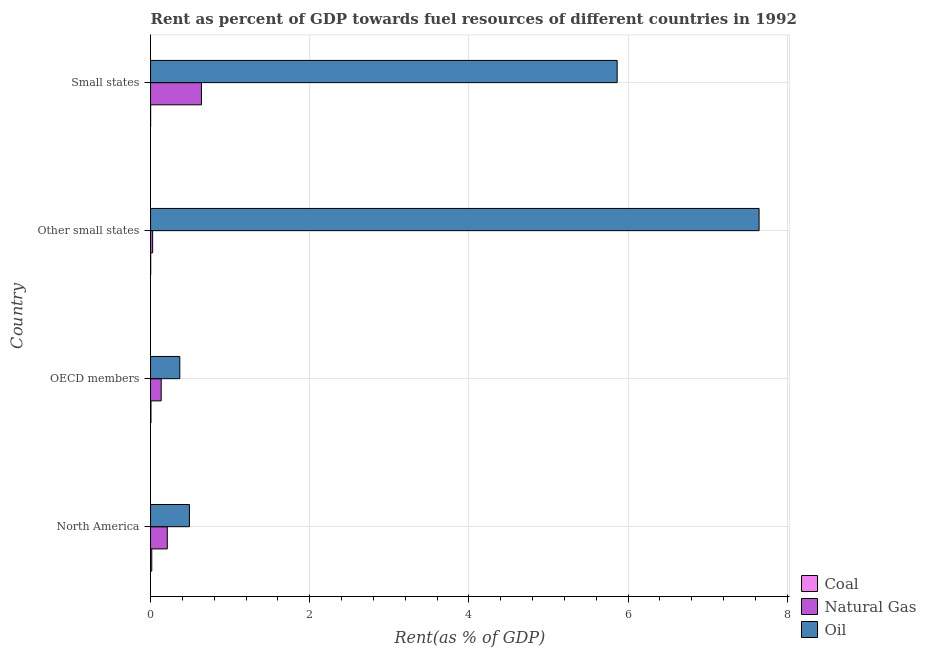Are the number of bars per tick equal to the number of legend labels?
Your answer should be very brief. Yes. Are the number of bars on each tick of the Y-axis equal?
Ensure brevity in your answer.  Yes. How many bars are there on the 4th tick from the top?
Your response must be concise. 3. How many bars are there on the 4th tick from the bottom?
Ensure brevity in your answer.  3. What is the label of the 2nd group of bars from the top?
Your answer should be very brief. Other small states. In how many cases, is the number of bars for a given country not equal to the number of legend labels?
Ensure brevity in your answer.  0. What is the rent towards coal in Small states?
Provide a short and direct response. 0. Across all countries, what is the maximum rent towards natural gas?
Make the answer very short. 0.64. Across all countries, what is the minimum rent towards oil?
Offer a terse response. 0.37. In which country was the rent towards natural gas maximum?
Provide a succinct answer. Small states. What is the total rent towards oil in the graph?
Offer a very short reply. 14.36. What is the difference between the rent towards natural gas in North America and that in OECD members?
Offer a terse response. 0.08. What is the difference between the rent towards natural gas in North America and the rent towards coal in Other small states?
Give a very brief answer. 0.21. What is the average rent towards coal per country?
Your answer should be very brief. 0.01. What is the difference between the rent towards coal and rent towards natural gas in OECD members?
Offer a very short reply. -0.13. In how many countries, is the rent towards oil greater than 4.8 %?
Your answer should be compact. 2. What is the ratio of the rent towards oil in North America to that in Other small states?
Offer a terse response. 0.06. Is the rent towards natural gas in North America less than that in Small states?
Your response must be concise. Yes. What is the difference between the highest and the second highest rent towards oil?
Keep it short and to the point. 1.78. What is the difference between the highest and the lowest rent towards oil?
Your answer should be very brief. 7.28. In how many countries, is the rent towards oil greater than the average rent towards oil taken over all countries?
Your answer should be compact. 2. What does the 1st bar from the top in North America represents?
Keep it short and to the point. Oil. What does the 2nd bar from the bottom in Small states represents?
Your answer should be compact. Natural Gas. How many bars are there?
Provide a short and direct response. 12. How many countries are there in the graph?
Keep it short and to the point. 4. Are the values on the major ticks of X-axis written in scientific E-notation?
Offer a terse response. No. Does the graph contain any zero values?
Provide a succinct answer. No. How many legend labels are there?
Offer a terse response. 3. How are the legend labels stacked?
Your answer should be very brief. Vertical. What is the title of the graph?
Offer a terse response. Rent as percent of GDP towards fuel resources of different countries in 1992. What is the label or title of the X-axis?
Make the answer very short. Rent(as % of GDP). What is the Rent(as % of GDP) of Coal in North America?
Make the answer very short. 0.02. What is the Rent(as % of GDP) in Natural Gas in North America?
Your answer should be compact. 0.21. What is the Rent(as % of GDP) in Oil in North America?
Offer a very short reply. 0.49. What is the Rent(as % of GDP) of Coal in OECD members?
Your answer should be very brief. 0.01. What is the Rent(as % of GDP) of Natural Gas in OECD members?
Make the answer very short. 0.13. What is the Rent(as % of GDP) of Oil in OECD members?
Your answer should be compact. 0.37. What is the Rent(as % of GDP) of Coal in Other small states?
Ensure brevity in your answer.  0. What is the Rent(as % of GDP) in Natural Gas in Other small states?
Give a very brief answer. 0.03. What is the Rent(as % of GDP) of Oil in Other small states?
Your answer should be compact. 7.65. What is the Rent(as % of GDP) in Coal in Small states?
Provide a short and direct response. 0. What is the Rent(as % of GDP) in Natural Gas in Small states?
Give a very brief answer. 0.64. What is the Rent(as % of GDP) of Oil in Small states?
Your response must be concise. 5.86. Across all countries, what is the maximum Rent(as % of GDP) of Coal?
Offer a terse response. 0.02. Across all countries, what is the maximum Rent(as % of GDP) of Natural Gas?
Offer a terse response. 0.64. Across all countries, what is the maximum Rent(as % of GDP) in Oil?
Give a very brief answer. 7.65. Across all countries, what is the minimum Rent(as % of GDP) of Coal?
Ensure brevity in your answer.  0. Across all countries, what is the minimum Rent(as % of GDP) of Natural Gas?
Keep it short and to the point. 0.03. Across all countries, what is the minimum Rent(as % of GDP) in Oil?
Provide a short and direct response. 0.37. What is the total Rent(as % of GDP) of Coal in the graph?
Offer a very short reply. 0.02. What is the total Rent(as % of GDP) of Natural Gas in the graph?
Ensure brevity in your answer.  1.01. What is the total Rent(as % of GDP) in Oil in the graph?
Your answer should be compact. 14.36. What is the difference between the Rent(as % of GDP) of Coal in North America and that in OECD members?
Provide a succinct answer. 0.01. What is the difference between the Rent(as % of GDP) of Natural Gas in North America and that in OECD members?
Ensure brevity in your answer.  0.08. What is the difference between the Rent(as % of GDP) in Oil in North America and that in OECD members?
Offer a terse response. 0.12. What is the difference between the Rent(as % of GDP) of Coal in North America and that in Other small states?
Your answer should be very brief. 0.01. What is the difference between the Rent(as % of GDP) in Natural Gas in North America and that in Other small states?
Your answer should be very brief. 0.18. What is the difference between the Rent(as % of GDP) of Oil in North America and that in Other small states?
Your response must be concise. -7.16. What is the difference between the Rent(as % of GDP) of Coal in North America and that in Small states?
Ensure brevity in your answer.  0.01. What is the difference between the Rent(as % of GDP) in Natural Gas in North America and that in Small states?
Offer a very short reply. -0.43. What is the difference between the Rent(as % of GDP) of Oil in North America and that in Small states?
Ensure brevity in your answer.  -5.37. What is the difference between the Rent(as % of GDP) in Coal in OECD members and that in Other small states?
Offer a terse response. 0. What is the difference between the Rent(as % of GDP) in Natural Gas in OECD members and that in Other small states?
Offer a terse response. 0.11. What is the difference between the Rent(as % of GDP) of Oil in OECD members and that in Other small states?
Offer a terse response. -7.28. What is the difference between the Rent(as % of GDP) of Coal in OECD members and that in Small states?
Provide a succinct answer. 0. What is the difference between the Rent(as % of GDP) in Natural Gas in OECD members and that in Small states?
Give a very brief answer. -0.51. What is the difference between the Rent(as % of GDP) of Oil in OECD members and that in Small states?
Ensure brevity in your answer.  -5.49. What is the difference between the Rent(as % of GDP) of Coal in Other small states and that in Small states?
Give a very brief answer. 0. What is the difference between the Rent(as % of GDP) in Natural Gas in Other small states and that in Small states?
Offer a very short reply. -0.61. What is the difference between the Rent(as % of GDP) of Oil in Other small states and that in Small states?
Make the answer very short. 1.78. What is the difference between the Rent(as % of GDP) in Coal in North America and the Rent(as % of GDP) in Natural Gas in OECD members?
Make the answer very short. -0.12. What is the difference between the Rent(as % of GDP) of Coal in North America and the Rent(as % of GDP) of Oil in OECD members?
Ensure brevity in your answer.  -0.35. What is the difference between the Rent(as % of GDP) of Natural Gas in North America and the Rent(as % of GDP) of Oil in OECD members?
Offer a terse response. -0.16. What is the difference between the Rent(as % of GDP) in Coal in North America and the Rent(as % of GDP) in Natural Gas in Other small states?
Keep it short and to the point. -0.01. What is the difference between the Rent(as % of GDP) of Coal in North America and the Rent(as % of GDP) of Oil in Other small states?
Your answer should be compact. -7.63. What is the difference between the Rent(as % of GDP) of Natural Gas in North America and the Rent(as % of GDP) of Oil in Other small states?
Ensure brevity in your answer.  -7.43. What is the difference between the Rent(as % of GDP) in Coal in North America and the Rent(as % of GDP) in Natural Gas in Small states?
Offer a terse response. -0.62. What is the difference between the Rent(as % of GDP) in Coal in North America and the Rent(as % of GDP) in Oil in Small states?
Keep it short and to the point. -5.85. What is the difference between the Rent(as % of GDP) of Natural Gas in North America and the Rent(as % of GDP) of Oil in Small states?
Ensure brevity in your answer.  -5.65. What is the difference between the Rent(as % of GDP) of Coal in OECD members and the Rent(as % of GDP) of Natural Gas in Other small states?
Ensure brevity in your answer.  -0.02. What is the difference between the Rent(as % of GDP) in Coal in OECD members and the Rent(as % of GDP) in Oil in Other small states?
Your answer should be very brief. -7.64. What is the difference between the Rent(as % of GDP) in Natural Gas in OECD members and the Rent(as % of GDP) in Oil in Other small states?
Provide a short and direct response. -7.51. What is the difference between the Rent(as % of GDP) in Coal in OECD members and the Rent(as % of GDP) in Natural Gas in Small states?
Provide a short and direct response. -0.63. What is the difference between the Rent(as % of GDP) in Coal in OECD members and the Rent(as % of GDP) in Oil in Small states?
Provide a succinct answer. -5.86. What is the difference between the Rent(as % of GDP) in Natural Gas in OECD members and the Rent(as % of GDP) in Oil in Small states?
Ensure brevity in your answer.  -5.73. What is the difference between the Rent(as % of GDP) in Coal in Other small states and the Rent(as % of GDP) in Natural Gas in Small states?
Your answer should be very brief. -0.64. What is the difference between the Rent(as % of GDP) of Coal in Other small states and the Rent(as % of GDP) of Oil in Small states?
Ensure brevity in your answer.  -5.86. What is the difference between the Rent(as % of GDP) of Natural Gas in Other small states and the Rent(as % of GDP) of Oil in Small states?
Your answer should be very brief. -5.84. What is the average Rent(as % of GDP) in Coal per country?
Keep it short and to the point. 0.01. What is the average Rent(as % of GDP) of Natural Gas per country?
Offer a very short reply. 0.25. What is the average Rent(as % of GDP) in Oil per country?
Provide a succinct answer. 3.59. What is the difference between the Rent(as % of GDP) of Coal and Rent(as % of GDP) of Natural Gas in North America?
Make the answer very short. -0.2. What is the difference between the Rent(as % of GDP) of Coal and Rent(as % of GDP) of Oil in North America?
Offer a very short reply. -0.47. What is the difference between the Rent(as % of GDP) in Natural Gas and Rent(as % of GDP) in Oil in North America?
Provide a short and direct response. -0.28. What is the difference between the Rent(as % of GDP) in Coal and Rent(as % of GDP) in Natural Gas in OECD members?
Offer a very short reply. -0.13. What is the difference between the Rent(as % of GDP) in Coal and Rent(as % of GDP) in Oil in OECD members?
Your answer should be very brief. -0.36. What is the difference between the Rent(as % of GDP) of Natural Gas and Rent(as % of GDP) of Oil in OECD members?
Provide a short and direct response. -0.23. What is the difference between the Rent(as % of GDP) in Coal and Rent(as % of GDP) in Natural Gas in Other small states?
Your response must be concise. -0.02. What is the difference between the Rent(as % of GDP) of Coal and Rent(as % of GDP) of Oil in Other small states?
Keep it short and to the point. -7.64. What is the difference between the Rent(as % of GDP) in Natural Gas and Rent(as % of GDP) in Oil in Other small states?
Your answer should be very brief. -7.62. What is the difference between the Rent(as % of GDP) of Coal and Rent(as % of GDP) of Natural Gas in Small states?
Ensure brevity in your answer.  -0.64. What is the difference between the Rent(as % of GDP) in Coal and Rent(as % of GDP) in Oil in Small states?
Your answer should be very brief. -5.86. What is the difference between the Rent(as % of GDP) in Natural Gas and Rent(as % of GDP) in Oil in Small states?
Make the answer very short. -5.22. What is the ratio of the Rent(as % of GDP) of Coal in North America to that in OECD members?
Your answer should be very brief. 2.9. What is the ratio of the Rent(as % of GDP) of Natural Gas in North America to that in OECD members?
Provide a succinct answer. 1.57. What is the ratio of the Rent(as % of GDP) of Oil in North America to that in OECD members?
Your answer should be very brief. 1.33. What is the ratio of the Rent(as % of GDP) of Coal in North America to that in Other small states?
Your answer should be very brief. 8.06. What is the ratio of the Rent(as % of GDP) of Natural Gas in North America to that in Other small states?
Provide a succinct answer. 7.91. What is the ratio of the Rent(as % of GDP) in Oil in North America to that in Other small states?
Ensure brevity in your answer.  0.06. What is the ratio of the Rent(as % of GDP) in Coal in North America to that in Small states?
Your answer should be compact. 15.48. What is the ratio of the Rent(as % of GDP) in Natural Gas in North America to that in Small states?
Provide a succinct answer. 0.33. What is the ratio of the Rent(as % of GDP) of Oil in North America to that in Small states?
Your response must be concise. 0.08. What is the ratio of the Rent(as % of GDP) of Coal in OECD members to that in Other small states?
Give a very brief answer. 2.79. What is the ratio of the Rent(as % of GDP) of Natural Gas in OECD members to that in Other small states?
Ensure brevity in your answer.  5.03. What is the ratio of the Rent(as % of GDP) of Oil in OECD members to that in Other small states?
Keep it short and to the point. 0.05. What is the ratio of the Rent(as % of GDP) of Coal in OECD members to that in Small states?
Offer a terse response. 5.35. What is the ratio of the Rent(as % of GDP) in Natural Gas in OECD members to that in Small states?
Provide a succinct answer. 0.21. What is the ratio of the Rent(as % of GDP) of Oil in OECD members to that in Small states?
Provide a succinct answer. 0.06. What is the ratio of the Rent(as % of GDP) in Coal in Other small states to that in Small states?
Give a very brief answer. 1.92. What is the ratio of the Rent(as % of GDP) of Natural Gas in Other small states to that in Small states?
Provide a short and direct response. 0.04. What is the ratio of the Rent(as % of GDP) of Oil in Other small states to that in Small states?
Offer a terse response. 1.3. What is the difference between the highest and the second highest Rent(as % of GDP) of Coal?
Your response must be concise. 0.01. What is the difference between the highest and the second highest Rent(as % of GDP) of Natural Gas?
Give a very brief answer. 0.43. What is the difference between the highest and the second highest Rent(as % of GDP) of Oil?
Keep it short and to the point. 1.78. What is the difference between the highest and the lowest Rent(as % of GDP) in Coal?
Offer a terse response. 0.01. What is the difference between the highest and the lowest Rent(as % of GDP) in Natural Gas?
Your answer should be compact. 0.61. What is the difference between the highest and the lowest Rent(as % of GDP) in Oil?
Provide a short and direct response. 7.28. 